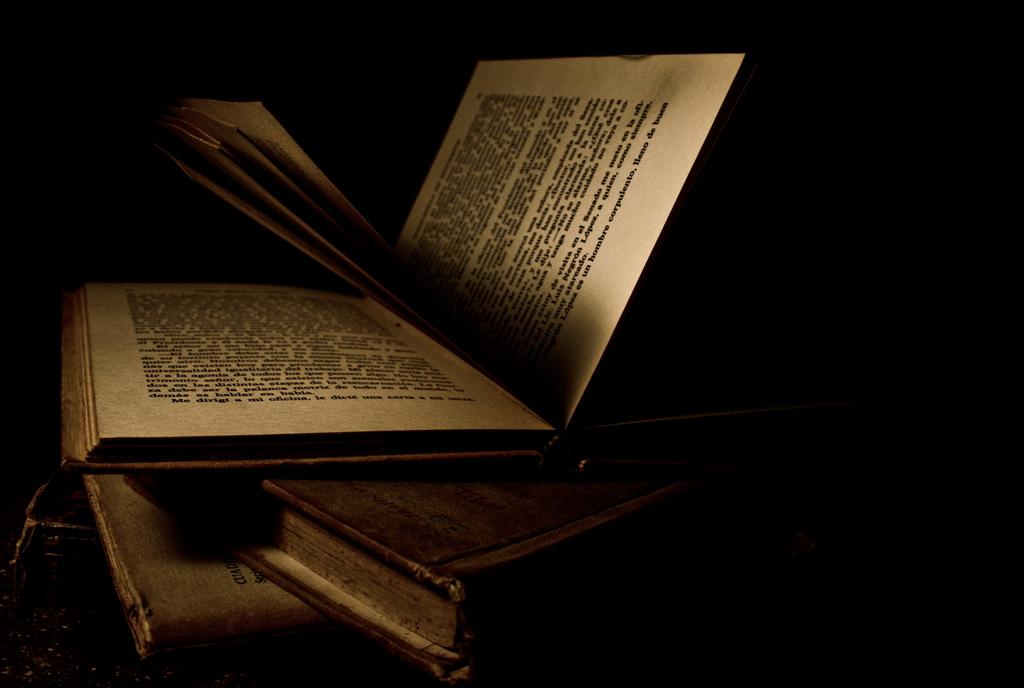<image>
Describe the image concisely. A book is open and says corpulento on the last line of the page. 